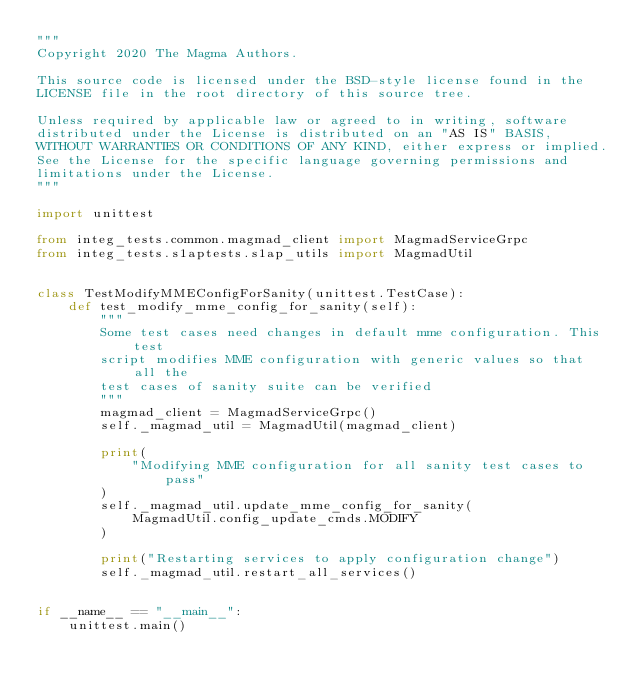Convert code to text. <code><loc_0><loc_0><loc_500><loc_500><_Python_>"""
Copyright 2020 The Magma Authors.

This source code is licensed under the BSD-style license found in the
LICENSE file in the root directory of this source tree.

Unless required by applicable law or agreed to in writing, software
distributed under the License is distributed on an "AS IS" BASIS,
WITHOUT WARRANTIES OR CONDITIONS OF ANY KIND, either express or implied.
See the License for the specific language governing permissions and
limitations under the License.
"""

import unittest

from integ_tests.common.magmad_client import MagmadServiceGrpc
from integ_tests.s1aptests.s1ap_utils import MagmadUtil


class TestModifyMMEConfigForSanity(unittest.TestCase):
    def test_modify_mme_config_for_sanity(self):
        """
        Some test cases need changes in default mme configuration. This test
        script modifies MME configuration with generic values so that all the
        test cases of sanity suite can be verified
        """
        magmad_client = MagmadServiceGrpc()
        self._magmad_util = MagmadUtil(magmad_client)

        print(
            "Modifying MME configuration for all sanity test cases to pass"
        )
        self._magmad_util.update_mme_config_for_sanity(
            MagmadUtil.config_update_cmds.MODIFY
        )

        print("Restarting services to apply configuration change")
        self._magmad_util.restart_all_services()


if __name__ == "__main__":
    unittest.main()
</code> 